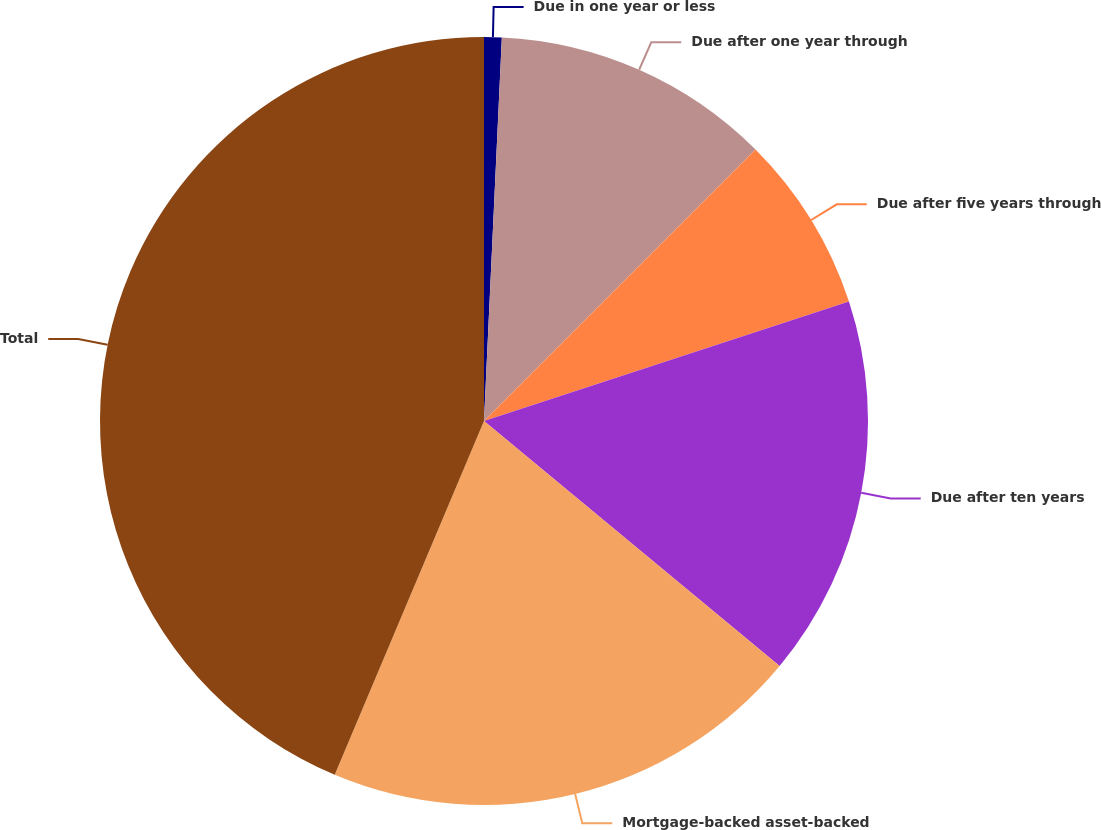Convert chart. <chart><loc_0><loc_0><loc_500><loc_500><pie_chart><fcel>Due in one year or less<fcel>Due after one year through<fcel>Due after five years through<fcel>Due after ten years<fcel>Mortgage-backed asset-backed<fcel>Total<nl><fcel>0.74%<fcel>11.76%<fcel>7.47%<fcel>16.05%<fcel>20.34%<fcel>43.65%<nl></chart> 